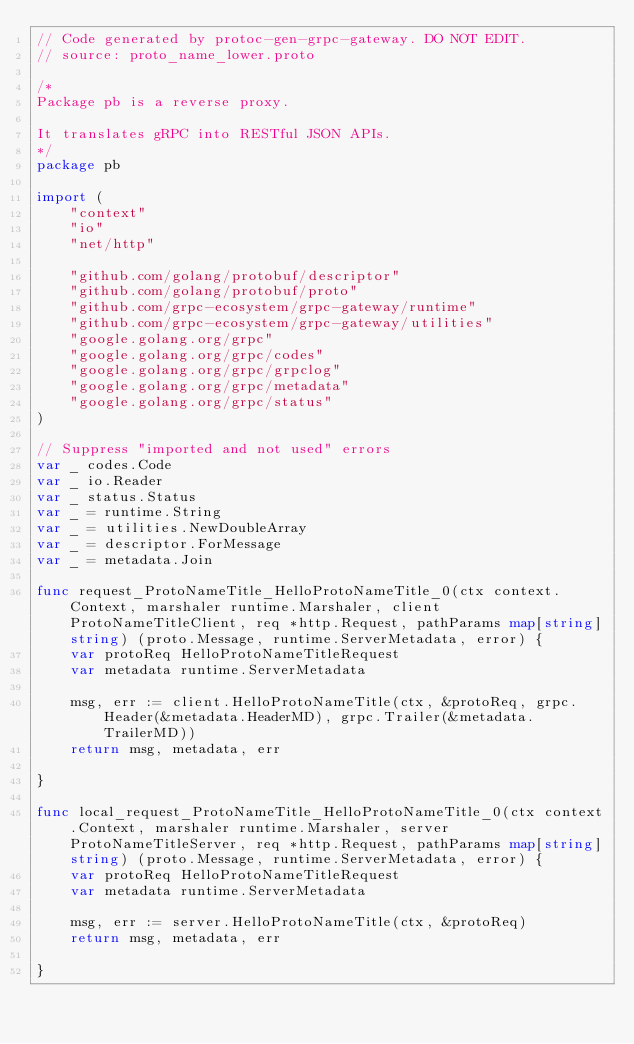<code> <loc_0><loc_0><loc_500><loc_500><_Go_>// Code generated by protoc-gen-grpc-gateway. DO NOT EDIT.
// source: proto_name_lower.proto

/*
Package pb is a reverse proxy.

It translates gRPC into RESTful JSON APIs.
*/
package pb

import (
	"context"
	"io"
	"net/http"

	"github.com/golang/protobuf/descriptor"
	"github.com/golang/protobuf/proto"
	"github.com/grpc-ecosystem/grpc-gateway/runtime"
	"github.com/grpc-ecosystem/grpc-gateway/utilities"
	"google.golang.org/grpc"
	"google.golang.org/grpc/codes"
	"google.golang.org/grpc/grpclog"
	"google.golang.org/grpc/metadata"
	"google.golang.org/grpc/status"
)

// Suppress "imported and not used" errors
var _ codes.Code
var _ io.Reader
var _ status.Status
var _ = runtime.String
var _ = utilities.NewDoubleArray
var _ = descriptor.ForMessage
var _ = metadata.Join

func request_ProtoNameTitle_HelloProtoNameTitle_0(ctx context.Context, marshaler runtime.Marshaler, client ProtoNameTitleClient, req *http.Request, pathParams map[string]string) (proto.Message, runtime.ServerMetadata, error) {
	var protoReq HelloProtoNameTitleRequest
	var metadata runtime.ServerMetadata

	msg, err := client.HelloProtoNameTitle(ctx, &protoReq, grpc.Header(&metadata.HeaderMD), grpc.Trailer(&metadata.TrailerMD))
	return msg, metadata, err

}

func local_request_ProtoNameTitle_HelloProtoNameTitle_0(ctx context.Context, marshaler runtime.Marshaler, server ProtoNameTitleServer, req *http.Request, pathParams map[string]string) (proto.Message, runtime.ServerMetadata, error) {
	var protoReq HelloProtoNameTitleRequest
	var metadata runtime.ServerMetadata

	msg, err := server.HelloProtoNameTitle(ctx, &protoReq)
	return msg, metadata, err

}
</code> 